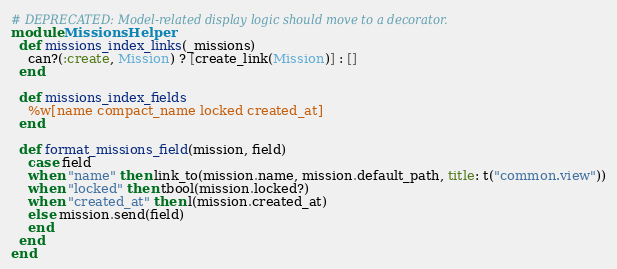Convert code to text. <code><loc_0><loc_0><loc_500><loc_500><_Ruby_>
# DEPRECATED: Model-related display logic should move to a decorator.
module MissionsHelper
  def missions_index_links(_missions)
    can?(:create, Mission) ? [create_link(Mission)] : []
  end

  def missions_index_fields
    %w[name compact_name locked created_at]
  end

  def format_missions_field(mission, field)
    case field
    when "name" then link_to(mission.name, mission.default_path, title: t("common.view"))
    when "locked" then tbool(mission.locked?)
    when "created_at" then l(mission.created_at)
    else mission.send(field)
    end
  end
end
</code> 